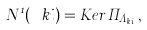<formula> <loc_0><loc_0><loc_500><loc_500>N ^ { 1 } ( \ k i ) = K e r \, \Pi _ { \Lambda _ { k , i } } ,</formula> 